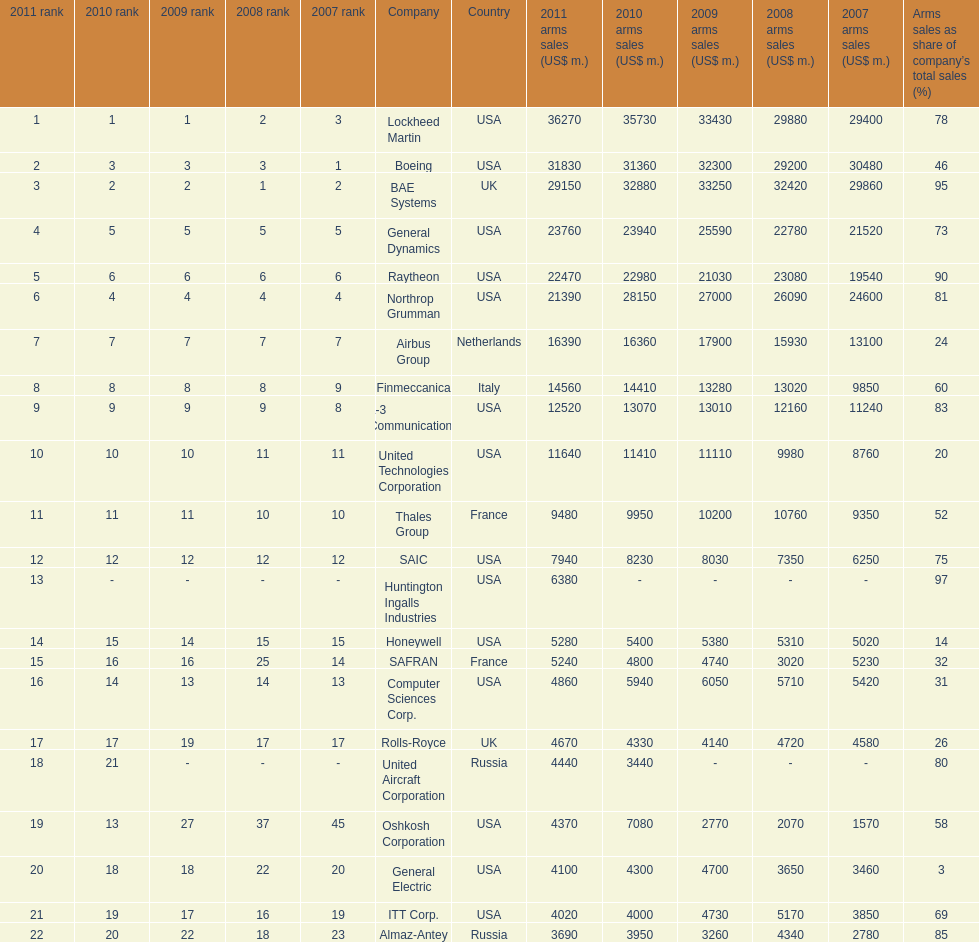How many companies are under the united states? 14. 